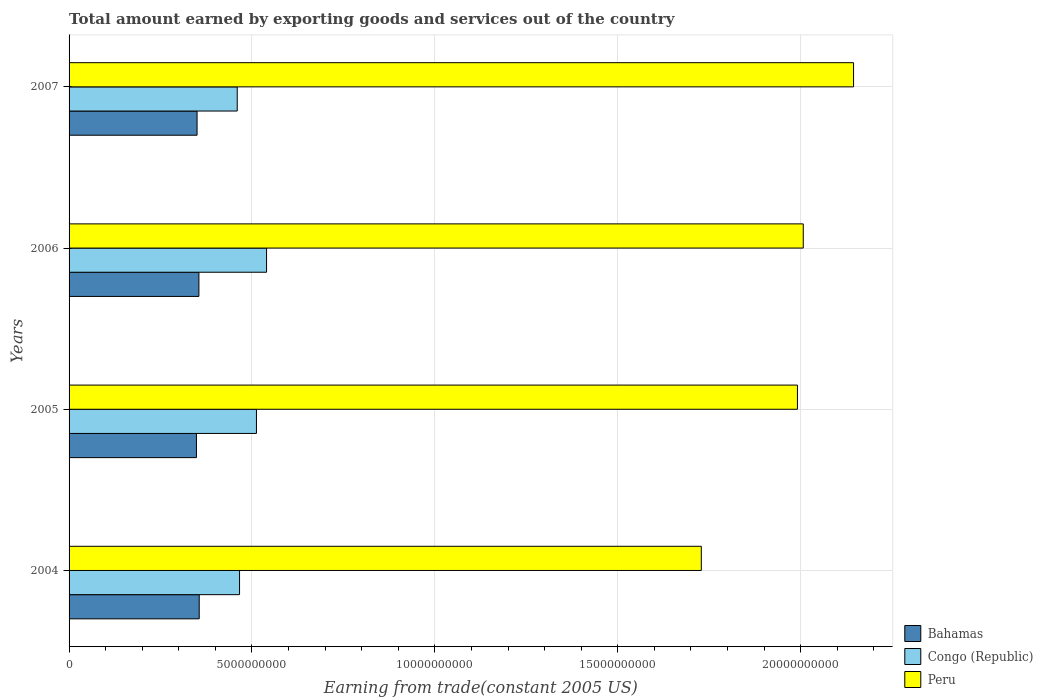How many groups of bars are there?
Your answer should be very brief. 4. Are the number of bars per tick equal to the number of legend labels?
Your response must be concise. Yes. Are the number of bars on each tick of the Y-axis equal?
Provide a short and direct response. Yes. How many bars are there on the 1st tick from the top?
Offer a very short reply. 3. How many bars are there on the 3rd tick from the bottom?
Offer a very short reply. 3. What is the label of the 1st group of bars from the top?
Offer a very short reply. 2007. In how many cases, is the number of bars for a given year not equal to the number of legend labels?
Keep it short and to the point. 0. What is the total amount earned by exporting goods and services in Congo (Republic) in 2007?
Your answer should be very brief. 4.60e+09. Across all years, what is the maximum total amount earned by exporting goods and services in Congo (Republic)?
Your response must be concise. 5.40e+09. Across all years, what is the minimum total amount earned by exporting goods and services in Congo (Republic)?
Provide a succinct answer. 4.60e+09. In which year was the total amount earned by exporting goods and services in Congo (Republic) maximum?
Make the answer very short. 2006. In which year was the total amount earned by exporting goods and services in Peru minimum?
Make the answer very short. 2004. What is the total total amount earned by exporting goods and services in Peru in the graph?
Keep it short and to the point. 7.87e+1. What is the difference between the total amount earned by exporting goods and services in Peru in 2005 and that in 2007?
Provide a short and direct response. -1.53e+09. What is the difference between the total amount earned by exporting goods and services in Peru in 2004 and the total amount earned by exporting goods and services in Congo (Republic) in 2005?
Keep it short and to the point. 1.22e+1. What is the average total amount earned by exporting goods and services in Congo (Republic) per year?
Provide a succinct answer. 4.94e+09. In the year 2006, what is the difference between the total amount earned by exporting goods and services in Peru and total amount earned by exporting goods and services in Bahamas?
Offer a terse response. 1.65e+1. What is the ratio of the total amount earned by exporting goods and services in Congo (Republic) in 2006 to that in 2007?
Your answer should be very brief. 1.17. Is the difference between the total amount earned by exporting goods and services in Peru in 2006 and 2007 greater than the difference between the total amount earned by exporting goods and services in Bahamas in 2006 and 2007?
Provide a succinct answer. No. What is the difference between the highest and the second highest total amount earned by exporting goods and services in Congo (Republic)?
Your answer should be very brief. 2.76e+08. What is the difference between the highest and the lowest total amount earned by exporting goods and services in Bahamas?
Ensure brevity in your answer.  7.62e+07. In how many years, is the total amount earned by exporting goods and services in Peru greater than the average total amount earned by exporting goods and services in Peru taken over all years?
Your answer should be compact. 3. What does the 1st bar from the top in 2006 represents?
Offer a terse response. Peru. What does the 1st bar from the bottom in 2004 represents?
Ensure brevity in your answer.  Bahamas. Are all the bars in the graph horizontal?
Ensure brevity in your answer.  Yes. How many years are there in the graph?
Offer a terse response. 4. Are the values on the major ticks of X-axis written in scientific E-notation?
Make the answer very short. No. Does the graph contain any zero values?
Make the answer very short. No. Where does the legend appear in the graph?
Provide a short and direct response. Bottom right. How are the legend labels stacked?
Keep it short and to the point. Vertical. What is the title of the graph?
Give a very brief answer. Total amount earned by exporting goods and services out of the country. What is the label or title of the X-axis?
Offer a very short reply. Earning from trade(constant 2005 US). What is the label or title of the Y-axis?
Provide a succinct answer. Years. What is the Earning from trade(constant 2005 US) of Bahamas in 2004?
Keep it short and to the point. 3.56e+09. What is the Earning from trade(constant 2005 US) in Congo (Republic) in 2004?
Your answer should be very brief. 4.66e+09. What is the Earning from trade(constant 2005 US) of Peru in 2004?
Offer a very short reply. 1.73e+1. What is the Earning from trade(constant 2005 US) of Bahamas in 2005?
Offer a terse response. 3.48e+09. What is the Earning from trade(constant 2005 US) of Congo (Republic) in 2005?
Provide a short and direct response. 5.12e+09. What is the Earning from trade(constant 2005 US) of Peru in 2005?
Your answer should be compact. 1.99e+1. What is the Earning from trade(constant 2005 US) of Bahamas in 2006?
Provide a succinct answer. 3.55e+09. What is the Earning from trade(constant 2005 US) in Congo (Republic) in 2006?
Make the answer very short. 5.40e+09. What is the Earning from trade(constant 2005 US) in Peru in 2006?
Provide a short and direct response. 2.01e+1. What is the Earning from trade(constant 2005 US) in Bahamas in 2007?
Make the answer very short. 3.50e+09. What is the Earning from trade(constant 2005 US) in Congo (Republic) in 2007?
Offer a terse response. 4.60e+09. What is the Earning from trade(constant 2005 US) in Peru in 2007?
Give a very brief answer. 2.14e+1. Across all years, what is the maximum Earning from trade(constant 2005 US) in Bahamas?
Ensure brevity in your answer.  3.56e+09. Across all years, what is the maximum Earning from trade(constant 2005 US) in Congo (Republic)?
Give a very brief answer. 5.40e+09. Across all years, what is the maximum Earning from trade(constant 2005 US) of Peru?
Provide a short and direct response. 2.14e+1. Across all years, what is the minimum Earning from trade(constant 2005 US) of Bahamas?
Offer a terse response. 3.48e+09. Across all years, what is the minimum Earning from trade(constant 2005 US) of Congo (Republic)?
Offer a terse response. 4.60e+09. Across all years, what is the minimum Earning from trade(constant 2005 US) in Peru?
Your response must be concise. 1.73e+1. What is the total Earning from trade(constant 2005 US) of Bahamas in the graph?
Make the answer very short. 1.41e+1. What is the total Earning from trade(constant 2005 US) of Congo (Republic) in the graph?
Offer a terse response. 1.98e+1. What is the total Earning from trade(constant 2005 US) of Peru in the graph?
Offer a terse response. 7.87e+1. What is the difference between the Earning from trade(constant 2005 US) of Bahamas in 2004 and that in 2005?
Provide a short and direct response. 7.62e+07. What is the difference between the Earning from trade(constant 2005 US) in Congo (Republic) in 2004 and that in 2005?
Give a very brief answer. -4.62e+08. What is the difference between the Earning from trade(constant 2005 US) in Peru in 2004 and that in 2005?
Offer a terse response. -2.63e+09. What is the difference between the Earning from trade(constant 2005 US) in Bahamas in 2004 and that in 2006?
Give a very brief answer. 8.46e+06. What is the difference between the Earning from trade(constant 2005 US) in Congo (Republic) in 2004 and that in 2006?
Provide a short and direct response. -7.39e+08. What is the difference between the Earning from trade(constant 2005 US) in Peru in 2004 and that in 2006?
Your answer should be very brief. -2.79e+09. What is the difference between the Earning from trade(constant 2005 US) of Bahamas in 2004 and that in 2007?
Make the answer very short. 5.91e+07. What is the difference between the Earning from trade(constant 2005 US) of Congo (Republic) in 2004 and that in 2007?
Your answer should be very brief. 6.33e+07. What is the difference between the Earning from trade(constant 2005 US) of Peru in 2004 and that in 2007?
Offer a terse response. -4.16e+09. What is the difference between the Earning from trade(constant 2005 US) in Bahamas in 2005 and that in 2006?
Provide a succinct answer. -6.77e+07. What is the difference between the Earning from trade(constant 2005 US) in Congo (Republic) in 2005 and that in 2006?
Keep it short and to the point. -2.76e+08. What is the difference between the Earning from trade(constant 2005 US) of Peru in 2005 and that in 2006?
Make the answer very short. -1.59e+08. What is the difference between the Earning from trade(constant 2005 US) in Bahamas in 2005 and that in 2007?
Offer a very short reply. -1.71e+07. What is the difference between the Earning from trade(constant 2005 US) in Congo (Republic) in 2005 and that in 2007?
Give a very brief answer. 5.25e+08. What is the difference between the Earning from trade(constant 2005 US) in Peru in 2005 and that in 2007?
Your answer should be very brief. -1.53e+09. What is the difference between the Earning from trade(constant 2005 US) of Bahamas in 2006 and that in 2007?
Give a very brief answer. 5.06e+07. What is the difference between the Earning from trade(constant 2005 US) in Congo (Republic) in 2006 and that in 2007?
Your answer should be compact. 8.02e+08. What is the difference between the Earning from trade(constant 2005 US) in Peru in 2006 and that in 2007?
Your response must be concise. -1.37e+09. What is the difference between the Earning from trade(constant 2005 US) in Bahamas in 2004 and the Earning from trade(constant 2005 US) in Congo (Republic) in 2005?
Make the answer very short. -1.56e+09. What is the difference between the Earning from trade(constant 2005 US) of Bahamas in 2004 and the Earning from trade(constant 2005 US) of Peru in 2005?
Your response must be concise. -1.64e+1. What is the difference between the Earning from trade(constant 2005 US) of Congo (Republic) in 2004 and the Earning from trade(constant 2005 US) of Peru in 2005?
Provide a succinct answer. -1.53e+1. What is the difference between the Earning from trade(constant 2005 US) in Bahamas in 2004 and the Earning from trade(constant 2005 US) in Congo (Republic) in 2006?
Your answer should be very brief. -1.84e+09. What is the difference between the Earning from trade(constant 2005 US) of Bahamas in 2004 and the Earning from trade(constant 2005 US) of Peru in 2006?
Keep it short and to the point. -1.65e+1. What is the difference between the Earning from trade(constant 2005 US) of Congo (Republic) in 2004 and the Earning from trade(constant 2005 US) of Peru in 2006?
Your answer should be very brief. -1.54e+1. What is the difference between the Earning from trade(constant 2005 US) in Bahamas in 2004 and the Earning from trade(constant 2005 US) in Congo (Republic) in 2007?
Keep it short and to the point. -1.04e+09. What is the difference between the Earning from trade(constant 2005 US) of Bahamas in 2004 and the Earning from trade(constant 2005 US) of Peru in 2007?
Your response must be concise. -1.79e+1. What is the difference between the Earning from trade(constant 2005 US) in Congo (Republic) in 2004 and the Earning from trade(constant 2005 US) in Peru in 2007?
Offer a very short reply. -1.68e+1. What is the difference between the Earning from trade(constant 2005 US) in Bahamas in 2005 and the Earning from trade(constant 2005 US) in Congo (Republic) in 2006?
Your response must be concise. -1.92e+09. What is the difference between the Earning from trade(constant 2005 US) of Bahamas in 2005 and the Earning from trade(constant 2005 US) of Peru in 2006?
Keep it short and to the point. -1.66e+1. What is the difference between the Earning from trade(constant 2005 US) of Congo (Republic) in 2005 and the Earning from trade(constant 2005 US) of Peru in 2006?
Give a very brief answer. -1.49e+1. What is the difference between the Earning from trade(constant 2005 US) in Bahamas in 2005 and the Earning from trade(constant 2005 US) in Congo (Republic) in 2007?
Make the answer very short. -1.12e+09. What is the difference between the Earning from trade(constant 2005 US) in Bahamas in 2005 and the Earning from trade(constant 2005 US) in Peru in 2007?
Provide a short and direct response. -1.80e+1. What is the difference between the Earning from trade(constant 2005 US) of Congo (Republic) in 2005 and the Earning from trade(constant 2005 US) of Peru in 2007?
Keep it short and to the point. -1.63e+1. What is the difference between the Earning from trade(constant 2005 US) of Bahamas in 2006 and the Earning from trade(constant 2005 US) of Congo (Republic) in 2007?
Keep it short and to the point. -1.05e+09. What is the difference between the Earning from trade(constant 2005 US) in Bahamas in 2006 and the Earning from trade(constant 2005 US) in Peru in 2007?
Offer a terse response. -1.79e+1. What is the difference between the Earning from trade(constant 2005 US) in Congo (Republic) in 2006 and the Earning from trade(constant 2005 US) in Peru in 2007?
Give a very brief answer. -1.60e+1. What is the average Earning from trade(constant 2005 US) in Bahamas per year?
Provide a succinct answer. 3.52e+09. What is the average Earning from trade(constant 2005 US) of Congo (Republic) per year?
Your answer should be compact. 4.94e+09. What is the average Earning from trade(constant 2005 US) of Peru per year?
Ensure brevity in your answer.  1.97e+1. In the year 2004, what is the difference between the Earning from trade(constant 2005 US) of Bahamas and Earning from trade(constant 2005 US) of Congo (Republic)?
Ensure brevity in your answer.  -1.10e+09. In the year 2004, what is the difference between the Earning from trade(constant 2005 US) in Bahamas and Earning from trade(constant 2005 US) in Peru?
Your answer should be compact. -1.37e+1. In the year 2004, what is the difference between the Earning from trade(constant 2005 US) of Congo (Republic) and Earning from trade(constant 2005 US) of Peru?
Offer a very short reply. -1.26e+1. In the year 2005, what is the difference between the Earning from trade(constant 2005 US) of Bahamas and Earning from trade(constant 2005 US) of Congo (Republic)?
Make the answer very short. -1.64e+09. In the year 2005, what is the difference between the Earning from trade(constant 2005 US) in Bahamas and Earning from trade(constant 2005 US) in Peru?
Provide a succinct answer. -1.64e+1. In the year 2005, what is the difference between the Earning from trade(constant 2005 US) in Congo (Republic) and Earning from trade(constant 2005 US) in Peru?
Give a very brief answer. -1.48e+1. In the year 2006, what is the difference between the Earning from trade(constant 2005 US) in Bahamas and Earning from trade(constant 2005 US) in Congo (Republic)?
Your answer should be compact. -1.85e+09. In the year 2006, what is the difference between the Earning from trade(constant 2005 US) in Bahamas and Earning from trade(constant 2005 US) in Peru?
Provide a succinct answer. -1.65e+1. In the year 2006, what is the difference between the Earning from trade(constant 2005 US) of Congo (Republic) and Earning from trade(constant 2005 US) of Peru?
Your response must be concise. -1.47e+1. In the year 2007, what is the difference between the Earning from trade(constant 2005 US) of Bahamas and Earning from trade(constant 2005 US) of Congo (Republic)?
Give a very brief answer. -1.10e+09. In the year 2007, what is the difference between the Earning from trade(constant 2005 US) in Bahamas and Earning from trade(constant 2005 US) in Peru?
Offer a very short reply. -1.79e+1. In the year 2007, what is the difference between the Earning from trade(constant 2005 US) of Congo (Republic) and Earning from trade(constant 2005 US) of Peru?
Offer a very short reply. -1.68e+1. What is the ratio of the Earning from trade(constant 2005 US) in Bahamas in 2004 to that in 2005?
Keep it short and to the point. 1.02. What is the ratio of the Earning from trade(constant 2005 US) in Congo (Republic) in 2004 to that in 2005?
Your response must be concise. 0.91. What is the ratio of the Earning from trade(constant 2005 US) in Peru in 2004 to that in 2005?
Offer a terse response. 0.87. What is the ratio of the Earning from trade(constant 2005 US) of Congo (Republic) in 2004 to that in 2006?
Provide a short and direct response. 0.86. What is the ratio of the Earning from trade(constant 2005 US) of Peru in 2004 to that in 2006?
Make the answer very short. 0.86. What is the ratio of the Earning from trade(constant 2005 US) in Bahamas in 2004 to that in 2007?
Ensure brevity in your answer.  1.02. What is the ratio of the Earning from trade(constant 2005 US) in Congo (Republic) in 2004 to that in 2007?
Your answer should be compact. 1.01. What is the ratio of the Earning from trade(constant 2005 US) in Peru in 2004 to that in 2007?
Offer a very short reply. 0.81. What is the ratio of the Earning from trade(constant 2005 US) of Bahamas in 2005 to that in 2006?
Your answer should be compact. 0.98. What is the ratio of the Earning from trade(constant 2005 US) of Congo (Republic) in 2005 to that in 2006?
Provide a short and direct response. 0.95. What is the ratio of the Earning from trade(constant 2005 US) of Peru in 2005 to that in 2006?
Provide a succinct answer. 0.99. What is the ratio of the Earning from trade(constant 2005 US) in Congo (Republic) in 2005 to that in 2007?
Give a very brief answer. 1.11. What is the ratio of the Earning from trade(constant 2005 US) of Peru in 2005 to that in 2007?
Offer a very short reply. 0.93. What is the ratio of the Earning from trade(constant 2005 US) of Bahamas in 2006 to that in 2007?
Provide a succinct answer. 1.01. What is the ratio of the Earning from trade(constant 2005 US) in Congo (Republic) in 2006 to that in 2007?
Make the answer very short. 1.17. What is the ratio of the Earning from trade(constant 2005 US) in Peru in 2006 to that in 2007?
Offer a terse response. 0.94. What is the difference between the highest and the second highest Earning from trade(constant 2005 US) in Bahamas?
Give a very brief answer. 8.46e+06. What is the difference between the highest and the second highest Earning from trade(constant 2005 US) in Congo (Republic)?
Provide a succinct answer. 2.76e+08. What is the difference between the highest and the second highest Earning from trade(constant 2005 US) in Peru?
Provide a short and direct response. 1.37e+09. What is the difference between the highest and the lowest Earning from trade(constant 2005 US) of Bahamas?
Your answer should be very brief. 7.62e+07. What is the difference between the highest and the lowest Earning from trade(constant 2005 US) of Congo (Republic)?
Offer a very short reply. 8.02e+08. What is the difference between the highest and the lowest Earning from trade(constant 2005 US) of Peru?
Keep it short and to the point. 4.16e+09. 